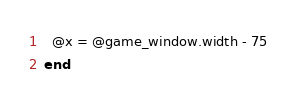<code> <loc_0><loc_0><loc_500><loc_500><_Ruby_>  @x = @game_window.width - 75
end
</code> 